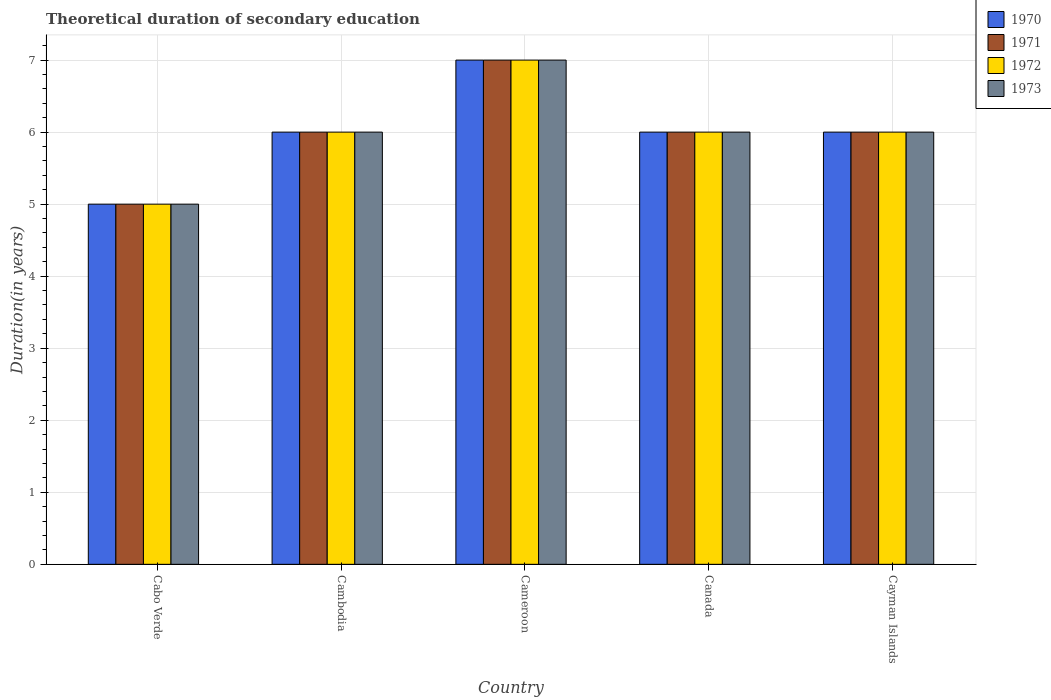How many groups of bars are there?
Give a very brief answer. 5. Are the number of bars per tick equal to the number of legend labels?
Your response must be concise. Yes. How many bars are there on the 4th tick from the left?
Provide a succinct answer. 4. What is the label of the 2nd group of bars from the left?
Provide a short and direct response. Cambodia. What is the total theoretical duration of secondary education in 1970 in Cameroon?
Give a very brief answer. 7. In which country was the total theoretical duration of secondary education in 1971 maximum?
Your response must be concise. Cameroon. In which country was the total theoretical duration of secondary education in 1973 minimum?
Keep it short and to the point. Cabo Verde. What is the difference between the total theoretical duration of secondary education in 1971 in Cabo Verde and that in Cameroon?
Ensure brevity in your answer.  -2. In how many countries, is the total theoretical duration of secondary education in 1970 greater than 1.6 years?
Provide a succinct answer. 5. What is the ratio of the total theoretical duration of secondary education in 1973 in Cabo Verde to that in Canada?
Give a very brief answer. 0.83. Is the difference between the total theoretical duration of secondary education in 1972 in Cambodia and Canada greater than the difference between the total theoretical duration of secondary education in 1970 in Cambodia and Canada?
Your answer should be compact. No. What is the difference between the highest and the lowest total theoretical duration of secondary education in 1972?
Ensure brevity in your answer.  2. In how many countries, is the total theoretical duration of secondary education in 1971 greater than the average total theoretical duration of secondary education in 1971 taken over all countries?
Your response must be concise. 1. What does the 2nd bar from the left in Cameroon represents?
Provide a succinct answer. 1971. What does the 2nd bar from the right in Cayman Islands represents?
Make the answer very short. 1972. How many countries are there in the graph?
Your answer should be compact. 5. Does the graph contain any zero values?
Provide a short and direct response. No. Does the graph contain grids?
Make the answer very short. Yes. Where does the legend appear in the graph?
Offer a very short reply. Top right. How are the legend labels stacked?
Ensure brevity in your answer.  Vertical. What is the title of the graph?
Provide a short and direct response. Theoretical duration of secondary education. What is the label or title of the X-axis?
Your response must be concise. Country. What is the label or title of the Y-axis?
Your answer should be compact. Duration(in years). What is the Duration(in years) in 1971 in Cabo Verde?
Give a very brief answer. 5. What is the Duration(in years) of 1973 in Cabo Verde?
Provide a short and direct response. 5. What is the Duration(in years) in 1971 in Cambodia?
Offer a terse response. 6. What is the Duration(in years) in 1971 in Cameroon?
Offer a very short reply. 7. What is the Duration(in years) in 1970 in Canada?
Offer a very short reply. 6. What is the Duration(in years) of 1972 in Canada?
Ensure brevity in your answer.  6. What is the Duration(in years) of 1972 in Cayman Islands?
Your response must be concise. 6. What is the Duration(in years) in 1973 in Cayman Islands?
Make the answer very short. 6. Across all countries, what is the maximum Duration(in years) of 1970?
Your answer should be compact. 7. Across all countries, what is the maximum Duration(in years) of 1972?
Offer a terse response. 7. What is the total Duration(in years) of 1971 in the graph?
Offer a very short reply. 30. What is the total Duration(in years) in 1973 in the graph?
Give a very brief answer. 30. What is the difference between the Duration(in years) of 1970 in Cabo Verde and that in Cambodia?
Offer a very short reply. -1. What is the difference between the Duration(in years) of 1971 in Cabo Verde and that in Cambodia?
Your response must be concise. -1. What is the difference between the Duration(in years) of 1972 in Cabo Verde and that in Cambodia?
Your answer should be very brief. -1. What is the difference between the Duration(in years) of 1970 in Cabo Verde and that in Cameroon?
Provide a succinct answer. -2. What is the difference between the Duration(in years) of 1971 in Cabo Verde and that in Cameroon?
Offer a terse response. -2. What is the difference between the Duration(in years) in 1972 in Cabo Verde and that in Cayman Islands?
Give a very brief answer. -1. What is the difference between the Duration(in years) of 1973 in Cambodia and that in Cameroon?
Your response must be concise. -1. What is the difference between the Duration(in years) of 1972 in Cambodia and that in Cayman Islands?
Your answer should be very brief. 0. What is the difference between the Duration(in years) in 1972 in Cameroon and that in Canada?
Your response must be concise. 1. What is the difference between the Duration(in years) in 1973 in Cameroon and that in Canada?
Offer a very short reply. 1. What is the difference between the Duration(in years) of 1970 in Cameroon and that in Cayman Islands?
Ensure brevity in your answer.  1. What is the difference between the Duration(in years) of 1970 in Canada and that in Cayman Islands?
Provide a short and direct response. 0. What is the difference between the Duration(in years) of 1970 in Cabo Verde and the Duration(in years) of 1972 in Cambodia?
Provide a short and direct response. -1. What is the difference between the Duration(in years) in 1970 in Cabo Verde and the Duration(in years) in 1973 in Cambodia?
Your answer should be very brief. -1. What is the difference between the Duration(in years) of 1971 in Cabo Verde and the Duration(in years) of 1973 in Cambodia?
Provide a succinct answer. -1. What is the difference between the Duration(in years) of 1972 in Cabo Verde and the Duration(in years) of 1973 in Cambodia?
Ensure brevity in your answer.  -1. What is the difference between the Duration(in years) of 1970 in Cabo Verde and the Duration(in years) of 1972 in Cameroon?
Offer a terse response. -2. What is the difference between the Duration(in years) of 1971 in Cabo Verde and the Duration(in years) of 1973 in Cameroon?
Your answer should be very brief. -2. What is the difference between the Duration(in years) in 1970 in Cabo Verde and the Duration(in years) in 1973 in Canada?
Make the answer very short. -1. What is the difference between the Duration(in years) of 1971 in Cabo Verde and the Duration(in years) of 1973 in Canada?
Give a very brief answer. -1. What is the difference between the Duration(in years) in 1970 in Cabo Verde and the Duration(in years) in 1971 in Cayman Islands?
Your answer should be compact. -1. What is the difference between the Duration(in years) in 1970 in Cabo Verde and the Duration(in years) in 1973 in Cayman Islands?
Ensure brevity in your answer.  -1. What is the difference between the Duration(in years) in 1971 in Cabo Verde and the Duration(in years) in 1972 in Cayman Islands?
Keep it short and to the point. -1. What is the difference between the Duration(in years) of 1971 in Cabo Verde and the Duration(in years) of 1973 in Cayman Islands?
Your answer should be compact. -1. What is the difference between the Duration(in years) of 1972 in Cabo Verde and the Duration(in years) of 1973 in Cayman Islands?
Your response must be concise. -1. What is the difference between the Duration(in years) in 1970 in Cambodia and the Duration(in years) in 1971 in Cameroon?
Your answer should be compact. -1. What is the difference between the Duration(in years) of 1970 in Cambodia and the Duration(in years) of 1972 in Cameroon?
Keep it short and to the point. -1. What is the difference between the Duration(in years) of 1970 in Cambodia and the Duration(in years) of 1973 in Cameroon?
Your response must be concise. -1. What is the difference between the Duration(in years) of 1972 in Cambodia and the Duration(in years) of 1973 in Cameroon?
Your answer should be compact. -1. What is the difference between the Duration(in years) in 1970 in Cambodia and the Duration(in years) in 1971 in Canada?
Offer a very short reply. 0. What is the difference between the Duration(in years) of 1970 in Cambodia and the Duration(in years) of 1972 in Canada?
Offer a very short reply. 0. What is the difference between the Duration(in years) of 1970 in Cambodia and the Duration(in years) of 1973 in Canada?
Your response must be concise. 0. What is the difference between the Duration(in years) in 1971 in Cambodia and the Duration(in years) in 1972 in Canada?
Keep it short and to the point. 0. What is the difference between the Duration(in years) of 1970 in Cambodia and the Duration(in years) of 1971 in Cayman Islands?
Make the answer very short. 0. What is the difference between the Duration(in years) of 1971 in Cambodia and the Duration(in years) of 1972 in Cayman Islands?
Make the answer very short. 0. What is the difference between the Duration(in years) of 1971 in Cambodia and the Duration(in years) of 1973 in Cayman Islands?
Give a very brief answer. 0. What is the difference between the Duration(in years) of 1972 in Cambodia and the Duration(in years) of 1973 in Cayman Islands?
Offer a very short reply. 0. What is the difference between the Duration(in years) in 1970 in Cameroon and the Duration(in years) in 1973 in Canada?
Offer a very short reply. 1. What is the difference between the Duration(in years) in 1972 in Cameroon and the Duration(in years) in 1973 in Canada?
Your response must be concise. 1. What is the difference between the Duration(in years) of 1970 in Cameroon and the Duration(in years) of 1971 in Cayman Islands?
Ensure brevity in your answer.  1. What is the difference between the Duration(in years) in 1970 in Canada and the Duration(in years) in 1971 in Cayman Islands?
Provide a succinct answer. 0. What is the difference between the Duration(in years) of 1971 in Canada and the Duration(in years) of 1972 in Cayman Islands?
Ensure brevity in your answer.  0. What is the difference between the Duration(in years) of 1972 in Canada and the Duration(in years) of 1973 in Cayman Islands?
Your response must be concise. 0. What is the average Duration(in years) of 1972 per country?
Your answer should be compact. 6. What is the difference between the Duration(in years) in 1970 and Duration(in years) in 1971 in Cabo Verde?
Provide a succinct answer. 0. What is the difference between the Duration(in years) of 1972 and Duration(in years) of 1973 in Cabo Verde?
Keep it short and to the point. 0. What is the difference between the Duration(in years) in 1970 and Duration(in years) in 1972 in Cambodia?
Offer a very short reply. 0. What is the difference between the Duration(in years) in 1970 and Duration(in years) in 1971 in Cameroon?
Offer a terse response. 0. What is the difference between the Duration(in years) in 1970 and Duration(in years) in 1973 in Cameroon?
Your answer should be very brief. 0. What is the difference between the Duration(in years) of 1971 and Duration(in years) of 1972 in Cameroon?
Keep it short and to the point. 0. What is the difference between the Duration(in years) of 1970 and Duration(in years) of 1972 in Canada?
Provide a short and direct response. 0. What is the difference between the Duration(in years) of 1971 and Duration(in years) of 1972 in Canada?
Keep it short and to the point. 0. What is the difference between the Duration(in years) of 1971 and Duration(in years) of 1973 in Canada?
Give a very brief answer. 0. What is the difference between the Duration(in years) of 1972 and Duration(in years) of 1973 in Canada?
Keep it short and to the point. 0. What is the difference between the Duration(in years) in 1970 and Duration(in years) in 1973 in Cayman Islands?
Your answer should be compact. 0. What is the difference between the Duration(in years) in 1971 and Duration(in years) in 1972 in Cayman Islands?
Your answer should be compact. 0. What is the difference between the Duration(in years) in 1971 and Duration(in years) in 1973 in Cayman Islands?
Keep it short and to the point. 0. What is the difference between the Duration(in years) of 1972 and Duration(in years) of 1973 in Cayman Islands?
Your answer should be very brief. 0. What is the ratio of the Duration(in years) in 1970 in Cabo Verde to that in Cambodia?
Offer a terse response. 0.83. What is the ratio of the Duration(in years) of 1971 in Cabo Verde to that in Cambodia?
Ensure brevity in your answer.  0.83. What is the ratio of the Duration(in years) of 1970 in Cabo Verde to that in Cameroon?
Keep it short and to the point. 0.71. What is the ratio of the Duration(in years) in 1972 in Cabo Verde to that in Cameroon?
Offer a terse response. 0.71. What is the ratio of the Duration(in years) of 1973 in Cabo Verde to that in Cameroon?
Offer a very short reply. 0.71. What is the ratio of the Duration(in years) in 1970 in Cabo Verde to that in Canada?
Keep it short and to the point. 0.83. What is the ratio of the Duration(in years) of 1971 in Cabo Verde to that in Canada?
Provide a succinct answer. 0.83. What is the ratio of the Duration(in years) of 1973 in Cabo Verde to that in Canada?
Keep it short and to the point. 0.83. What is the ratio of the Duration(in years) in 1970 in Cabo Verde to that in Cayman Islands?
Offer a terse response. 0.83. What is the ratio of the Duration(in years) in 1971 in Cabo Verde to that in Cayman Islands?
Your response must be concise. 0.83. What is the ratio of the Duration(in years) in 1972 in Cabo Verde to that in Cayman Islands?
Keep it short and to the point. 0.83. What is the ratio of the Duration(in years) of 1970 in Cambodia to that in Cameroon?
Ensure brevity in your answer.  0.86. What is the ratio of the Duration(in years) in 1971 in Cambodia to that in Cameroon?
Make the answer very short. 0.86. What is the ratio of the Duration(in years) of 1972 in Cambodia to that in Cameroon?
Offer a terse response. 0.86. What is the ratio of the Duration(in years) of 1971 in Cambodia to that in Canada?
Ensure brevity in your answer.  1. What is the ratio of the Duration(in years) of 1972 in Cambodia to that in Canada?
Keep it short and to the point. 1. What is the ratio of the Duration(in years) in 1973 in Cambodia to that in Cayman Islands?
Provide a succinct answer. 1. What is the ratio of the Duration(in years) of 1970 in Cameroon to that in Canada?
Offer a very short reply. 1.17. What is the ratio of the Duration(in years) in 1973 in Cameroon to that in Canada?
Provide a short and direct response. 1.17. What is the ratio of the Duration(in years) of 1971 in Cameroon to that in Cayman Islands?
Offer a very short reply. 1.17. What is the ratio of the Duration(in years) in 1973 in Cameroon to that in Cayman Islands?
Provide a short and direct response. 1.17. What is the ratio of the Duration(in years) of 1970 in Canada to that in Cayman Islands?
Keep it short and to the point. 1. What is the ratio of the Duration(in years) in 1971 in Canada to that in Cayman Islands?
Your answer should be compact. 1. What is the ratio of the Duration(in years) in 1973 in Canada to that in Cayman Islands?
Your answer should be compact. 1. What is the difference between the highest and the second highest Duration(in years) of 1971?
Your response must be concise. 1. What is the difference between the highest and the lowest Duration(in years) in 1971?
Your response must be concise. 2. What is the difference between the highest and the lowest Duration(in years) in 1973?
Your response must be concise. 2. 